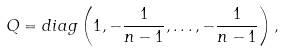Convert formula to latex. <formula><loc_0><loc_0><loc_500><loc_500>Q = d i a g \left ( 1 , - { \frac { 1 } { n - 1 } } , \dots , - { \frac { 1 } { n - 1 } } \right ) ,</formula> 